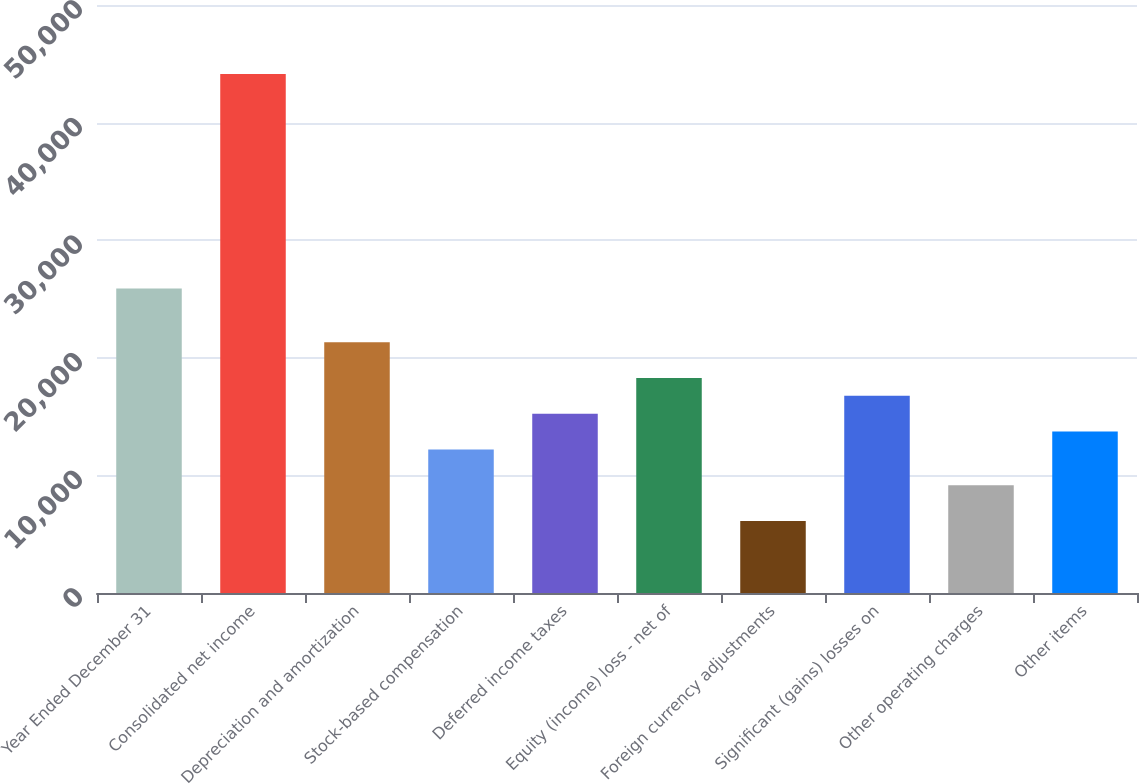<chart> <loc_0><loc_0><loc_500><loc_500><bar_chart><fcel>Year Ended December 31<fcel>Consolidated net income<fcel>Depreciation and amortization<fcel>Stock-based compensation<fcel>Deferred income taxes<fcel>Equity (income) loss - net of<fcel>Foreign currency adjustments<fcel>Significant (gains) losses on<fcel>Other operating charges<fcel>Other items<nl><fcel>25891.7<fcel>44132.9<fcel>21331.4<fcel>12210.8<fcel>15251<fcel>18291.2<fcel>6130.4<fcel>16771.1<fcel>9170.6<fcel>13730.9<nl></chart> 